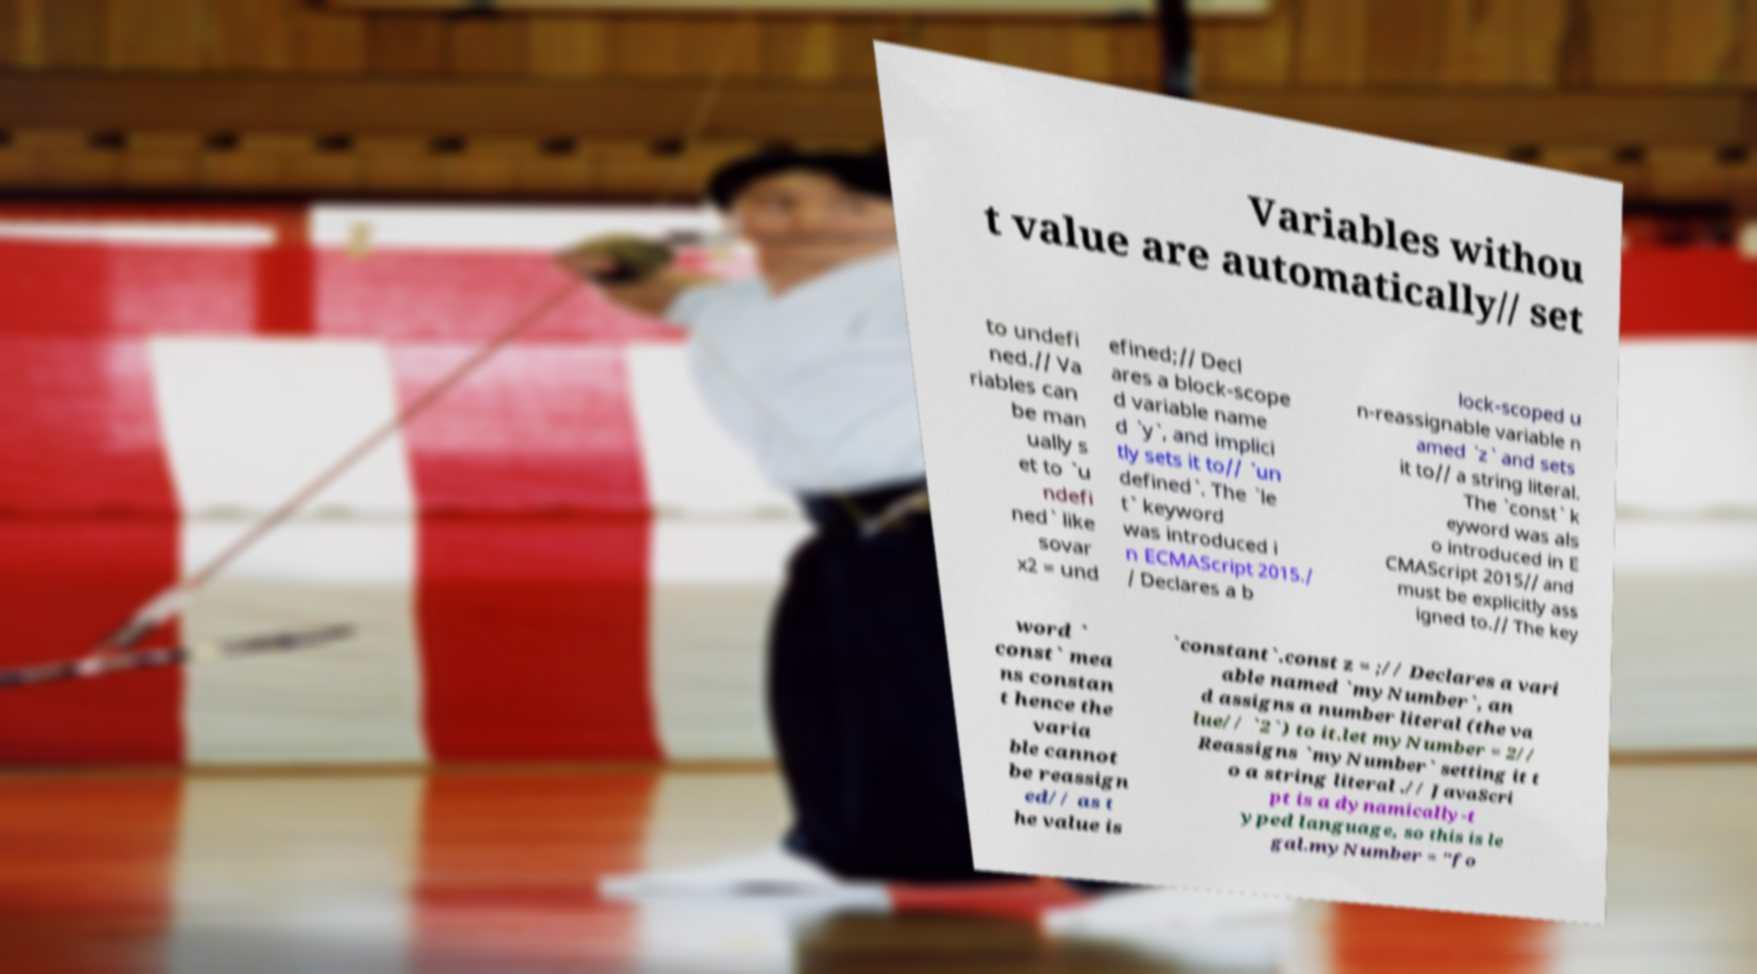Please read and relay the text visible in this image. What does it say? Variables withou t value are automatically// set to undefi ned.// Va riables can be man ually s et to `u ndefi ned` like sovar x2 = und efined;// Decl ares a block-scope d variable name d `y`, and implici tly sets it to// `un defined`. The `le t` keyword was introduced i n ECMAScript 2015./ / Declares a b lock-scoped u n-reassignable variable n amed `z` and sets it to// a string literal. The `const` k eyword was als o introduced in E CMAScript 2015// and must be explicitly ass igned to.// The key word ` const` mea ns constan t hence the varia ble cannot be reassign ed// as t he value is `constant`.const z = ;// Declares a vari able named `myNumber`, an d assigns a number literal (the va lue// `2`) to it.let myNumber = 2// Reassigns `myNumber` setting it t o a string literal .// JavaScri pt is a dynamically-t yped language, so this is le gal.myNumber = "fo 